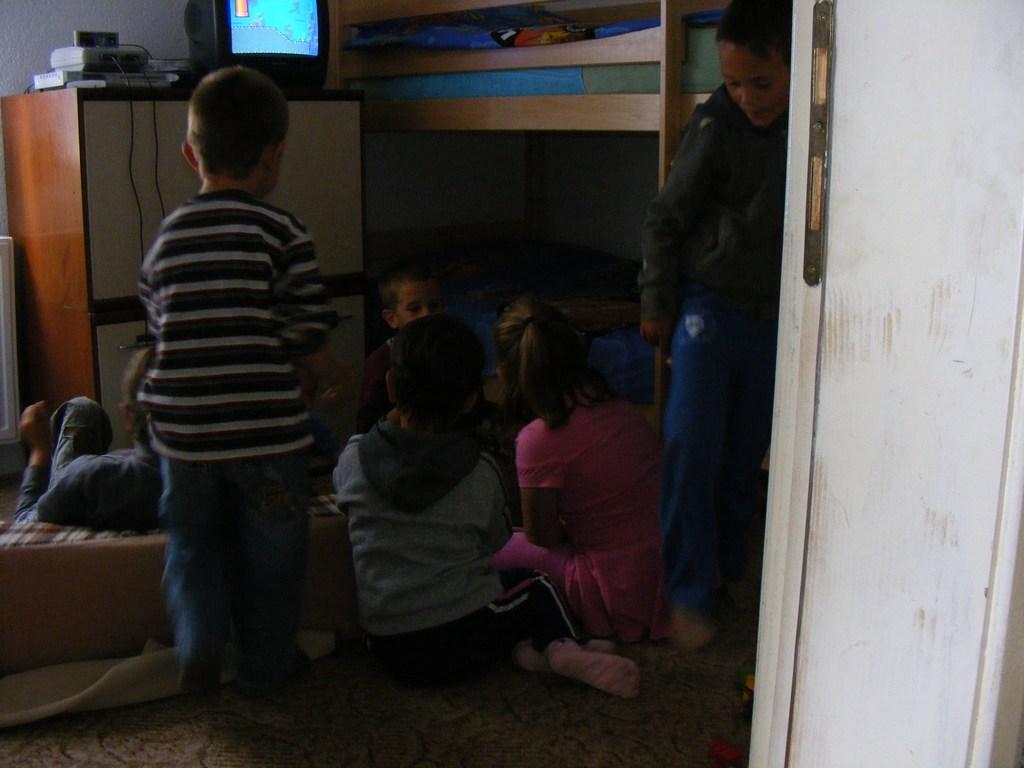Can you describe this image briefly? In this image we can see few children. In the back we can see a cabinet. On that there is a TV and some other devices. Also we can see a bunk bed. On the floor there is cloth and some other object. 